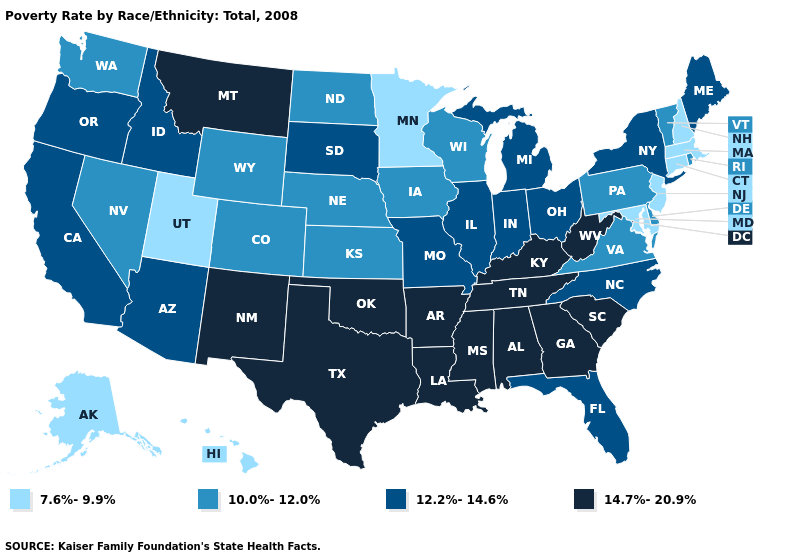Name the states that have a value in the range 10.0%-12.0%?
Give a very brief answer. Colorado, Delaware, Iowa, Kansas, Nebraska, Nevada, North Dakota, Pennsylvania, Rhode Island, Vermont, Virginia, Washington, Wisconsin, Wyoming. What is the value of Iowa?
Write a very short answer. 10.0%-12.0%. Which states hav the highest value in the South?
Write a very short answer. Alabama, Arkansas, Georgia, Kentucky, Louisiana, Mississippi, Oklahoma, South Carolina, Tennessee, Texas, West Virginia. Among the states that border Indiana , does Kentucky have the lowest value?
Give a very brief answer. No. What is the highest value in the West ?
Keep it brief. 14.7%-20.9%. What is the lowest value in the MidWest?
Write a very short answer. 7.6%-9.9%. Does the first symbol in the legend represent the smallest category?
Be succinct. Yes. What is the lowest value in states that border Kansas?
Concise answer only. 10.0%-12.0%. Among the states that border Maine , which have the highest value?
Write a very short answer. New Hampshire. What is the value of Arizona?
Keep it brief. 12.2%-14.6%. Does the first symbol in the legend represent the smallest category?
Be succinct. Yes. Does Kansas have the highest value in the USA?
Be succinct. No. Name the states that have a value in the range 10.0%-12.0%?
Quick response, please. Colorado, Delaware, Iowa, Kansas, Nebraska, Nevada, North Dakota, Pennsylvania, Rhode Island, Vermont, Virginia, Washington, Wisconsin, Wyoming. Does Massachusetts have the highest value in the Northeast?
Be succinct. No. Does North Dakota have the lowest value in the MidWest?
Quick response, please. No. 